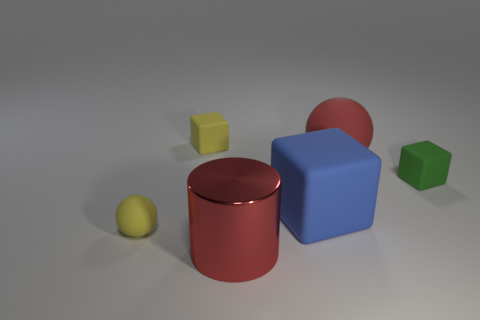There is a large cylinder that is the same color as the big ball; what material is it?
Offer a very short reply. Metal. There is a cube to the left of the red cylinder; is its color the same as the small sphere?
Offer a terse response. Yes. The big cylinder has what color?
Give a very brief answer. Red. What shape is the red thing in front of the yellow matte thing left of the tiny yellow rubber cube to the right of the yellow sphere?
Your answer should be very brief. Cylinder. What material is the small cube that is on the right side of the rubber block on the left side of the blue matte object?
Ensure brevity in your answer.  Rubber. What shape is the red thing that is made of the same material as the yellow ball?
Provide a short and direct response. Sphere. Are there any other things that are the same shape as the big metal object?
Provide a succinct answer. No. What number of small green blocks are in front of the large red matte thing?
Your response must be concise. 1. Are any large red cylinders visible?
Provide a succinct answer. Yes. What color is the big rubber thing left of the sphere that is behind the tiny rubber object that is in front of the green thing?
Keep it short and to the point. Blue. 